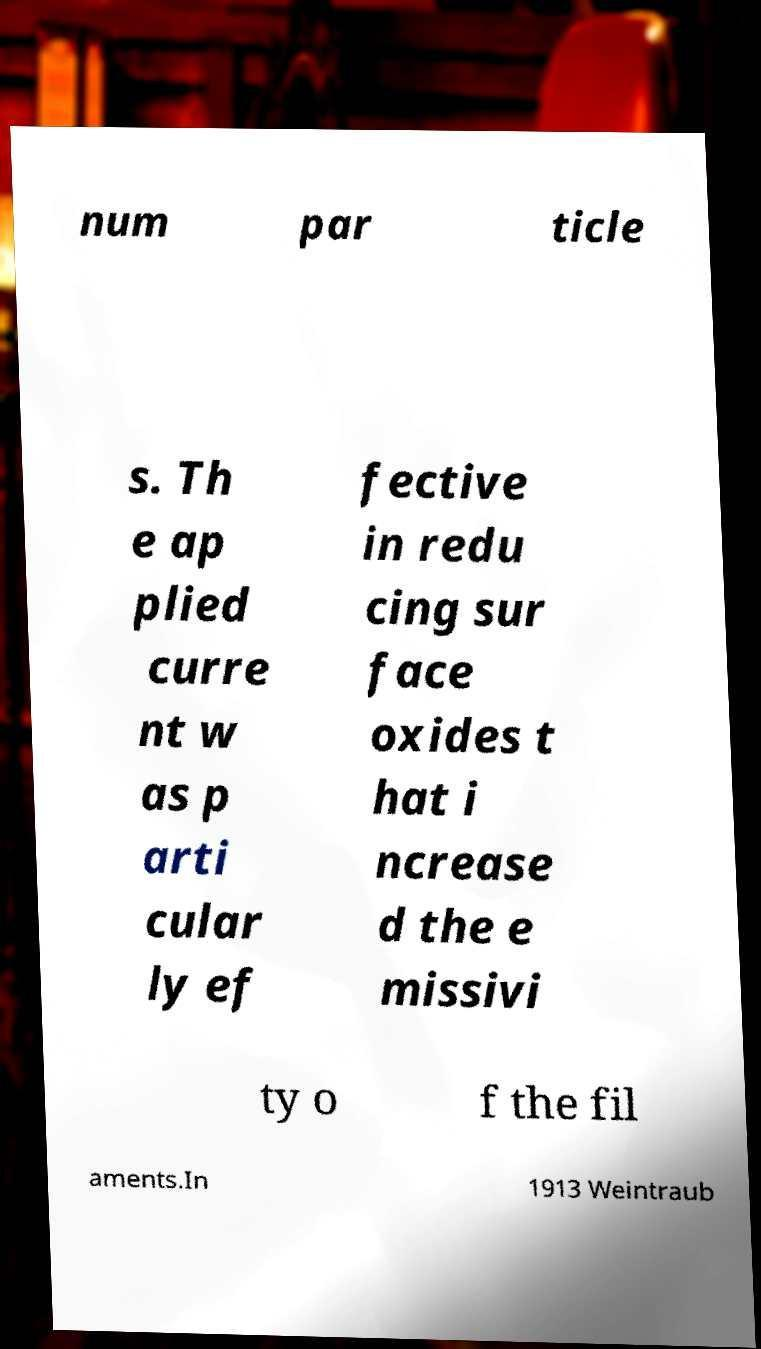What messages or text are displayed in this image? I need them in a readable, typed format. num par ticle s. Th e ap plied curre nt w as p arti cular ly ef fective in redu cing sur face oxides t hat i ncrease d the e missivi ty o f the fil aments.In 1913 Weintraub 